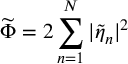Convert formula to latex. <formula><loc_0><loc_0><loc_500><loc_500>\widetilde { \Phi } = 2 \sum _ { n = 1 } ^ { N } | \widetilde { \eta } _ { n } | ^ { 2 }</formula> 